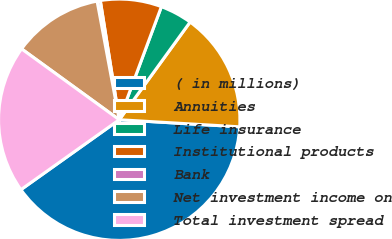Convert chart to OTSL. <chart><loc_0><loc_0><loc_500><loc_500><pie_chart><fcel>( in millions)<fcel>Annuities<fcel>Life insurance<fcel>Institutional products<fcel>Bank<fcel>Net investment income on<fcel>Total investment spread<nl><fcel>39.23%<fcel>15.95%<fcel>4.31%<fcel>8.19%<fcel>0.43%<fcel>12.07%<fcel>19.83%<nl></chart> 